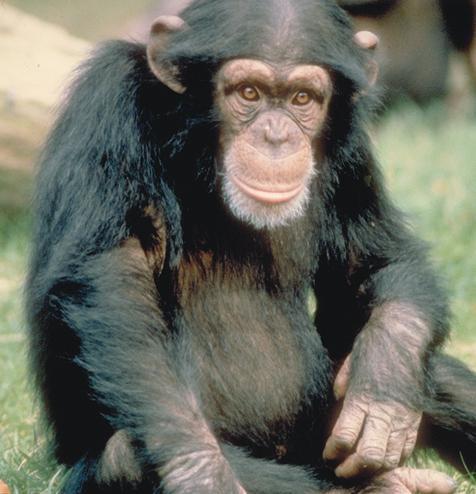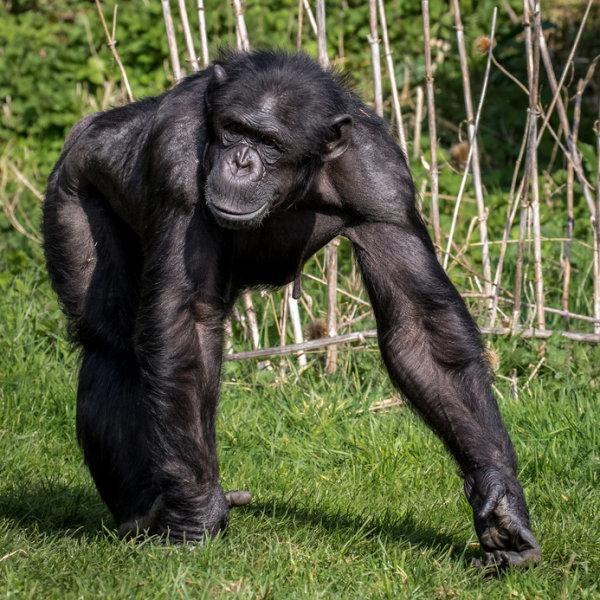The first image is the image on the left, the second image is the image on the right. For the images displayed, is the sentence "An image shows at least one young chimp with an older chimp nearby." factually correct? Answer yes or no. No. 